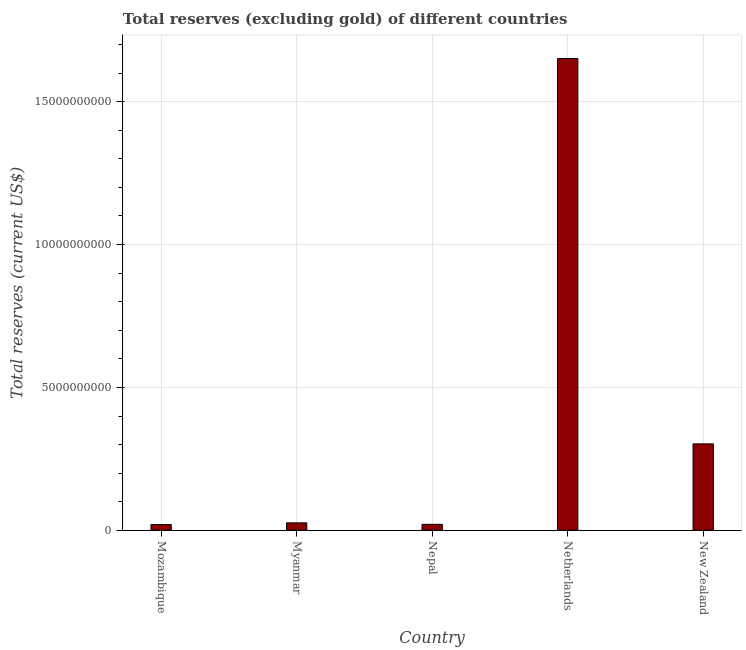Does the graph contain any zero values?
Offer a terse response. No. Does the graph contain grids?
Provide a succinct answer. Yes. What is the title of the graph?
Your answer should be compact. Total reserves (excluding gold) of different countries. What is the label or title of the X-axis?
Keep it short and to the point. Country. What is the label or title of the Y-axis?
Your answer should be very brief. Total reserves (current US$). What is the total reserves (excluding gold) in Netherlands?
Keep it short and to the point. 1.65e+1. Across all countries, what is the maximum total reserves (excluding gold)?
Keep it short and to the point. 1.65e+1. Across all countries, what is the minimum total reserves (excluding gold)?
Offer a terse response. 2.03e+08. In which country was the total reserves (excluding gold) minimum?
Ensure brevity in your answer.  Mozambique. What is the sum of the total reserves (excluding gold)?
Offer a very short reply. 2.02e+1. What is the difference between the total reserves (excluding gold) in Nepal and New Zealand?
Your response must be concise. -2.82e+09. What is the average total reserves (excluding gold) per country?
Provide a succinct answer. 4.04e+09. What is the median total reserves (excluding gold)?
Your response must be concise. 2.63e+08. What is the ratio of the total reserves (excluding gold) in Myanmar to that in Netherlands?
Ensure brevity in your answer.  0.02. What is the difference between the highest and the second highest total reserves (excluding gold)?
Your response must be concise. 1.35e+1. Is the sum of the total reserves (excluding gold) in Mozambique and Myanmar greater than the maximum total reserves (excluding gold) across all countries?
Ensure brevity in your answer.  No. What is the difference between the highest and the lowest total reserves (excluding gold)?
Provide a short and direct response. 1.63e+1. In how many countries, is the total reserves (excluding gold) greater than the average total reserves (excluding gold) taken over all countries?
Your answer should be very brief. 1. How many bars are there?
Make the answer very short. 5. How many countries are there in the graph?
Your response must be concise. 5. What is the difference between two consecutive major ticks on the Y-axis?
Your answer should be compact. 5.00e+09. What is the Total reserves (current US$) in Mozambique?
Keep it short and to the point. 2.03e+08. What is the Total reserves (current US$) in Myanmar?
Your answer should be compact. 2.63e+08. What is the Total reserves (current US$) of Nepal?
Your response must be concise. 2.12e+08. What is the Total reserves (current US$) of Netherlands?
Give a very brief answer. 1.65e+1. What is the Total reserves (current US$) in New Zealand?
Make the answer very short. 3.03e+09. What is the difference between the Total reserves (current US$) in Mozambique and Myanmar?
Your answer should be compact. -5.99e+07. What is the difference between the Total reserves (current US$) in Mozambique and Nepal?
Make the answer very short. -8.08e+06. What is the difference between the Total reserves (current US$) in Mozambique and Netherlands?
Offer a terse response. -1.63e+1. What is the difference between the Total reserves (current US$) in Mozambique and New Zealand?
Keep it short and to the point. -2.82e+09. What is the difference between the Total reserves (current US$) in Myanmar and Nepal?
Offer a very short reply. 5.18e+07. What is the difference between the Total reserves (current US$) in Myanmar and Netherlands?
Give a very brief answer. -1.62e+1. What is the difference between the Total reserves (current US$) in Myanmar and New Zealand?
Make the answer very short. -2.76e+09. What is the difference between the Total reserves (current US$) in Nepal and Netherlands?
Your response must be concise. -1.63e+1. What is the difference between the Total reserves (current US$) in Nepal and New Zealand?
Offer a very short reply. -2.82e+09. What is the difference between the Total reserves (current US$) in Netherlands and New Zealand?
Your response must be concise. 1.35e+1. What is the ratio of the Total reserves (current US$) in Mozambique to that in Myanmar?
Your answer should be very brief. 0.77. What is the ratio of the Total reserves (current US$) in Mozambique to that in Netherlands?
Make the answer very short. 0.01. What is the ratio of the Total reserves (current US$) in Mozambique to that in New Zealand?
Offer a terse response. 0.07. What is the ratio of the Total reserves (current US$) in Myanmar to that in Nepal?
Keep it short and to the point. 1.25. What is the ratio of the Total reserves (current US$) in Myanmar to that in Netherlands?
Provide a short and direct response. 0.02. What is the ratio of the Total reserves (current US$) in Myanmar to that in New Zealand?
Offer a terse response. 0.09. What is the ratio of the Total reserves (current US$) in Nepal to that in Netherlands?
Your answer should be very brief. 0.01. What is the ratio of the Total reserves (current US$) in Nepal to that in New Zealand?
Make the answer very short. 0.07. What is the ratio of the Total reserves (current US$) in Netherlands to that in New Zealand?
Provide a short and direct response. 5.45. 